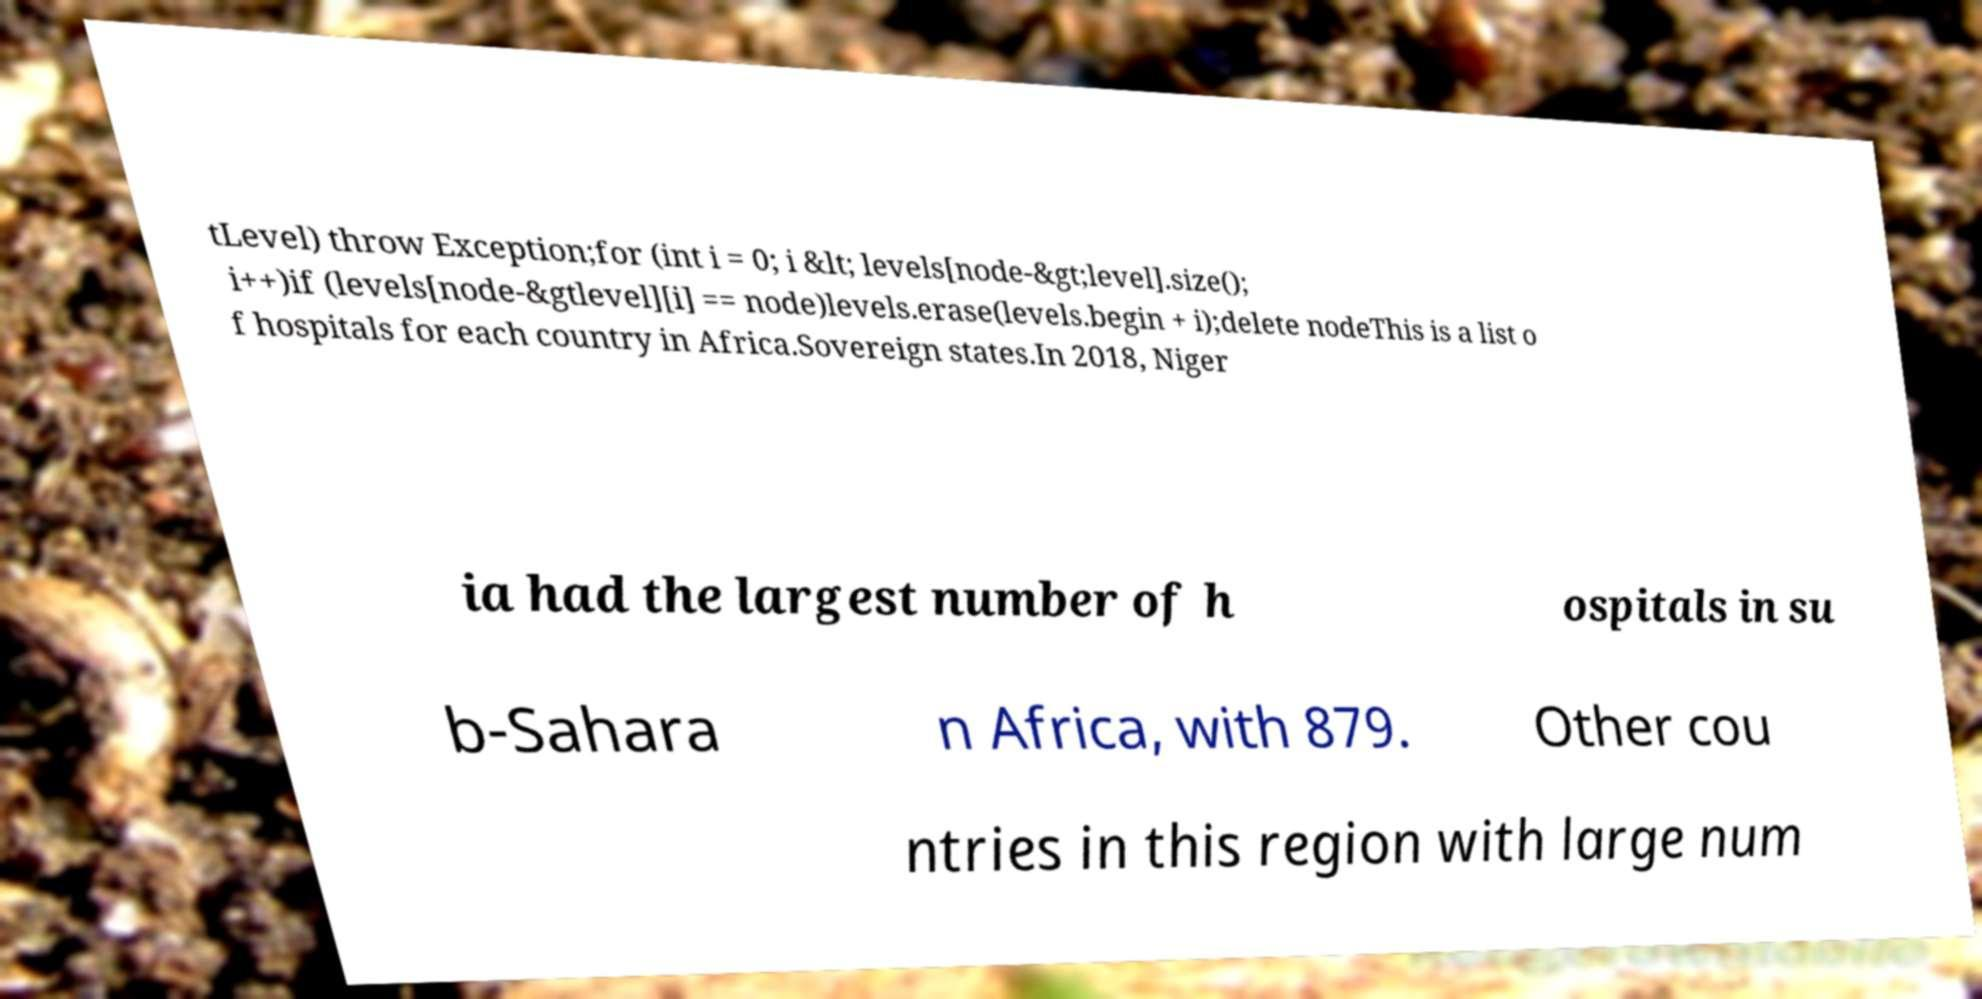For documentation purposes, I need the text within this image transcribed. Could you provide that? tLevel) throw Exception;for (int i = 0; i &lt; levels[node-&gt;level].size(); i++)if (levels[node-&gtlevel][i] == node)levels.erase(levels.begin + i);delete nodeThis is a list o f hospitals for each country in Africa.Sovereign states.In 2018, Niger ia had the largest number of h ospitals in su b-Sahara n Africa, with 879. Other cou ntries in this region with large num 